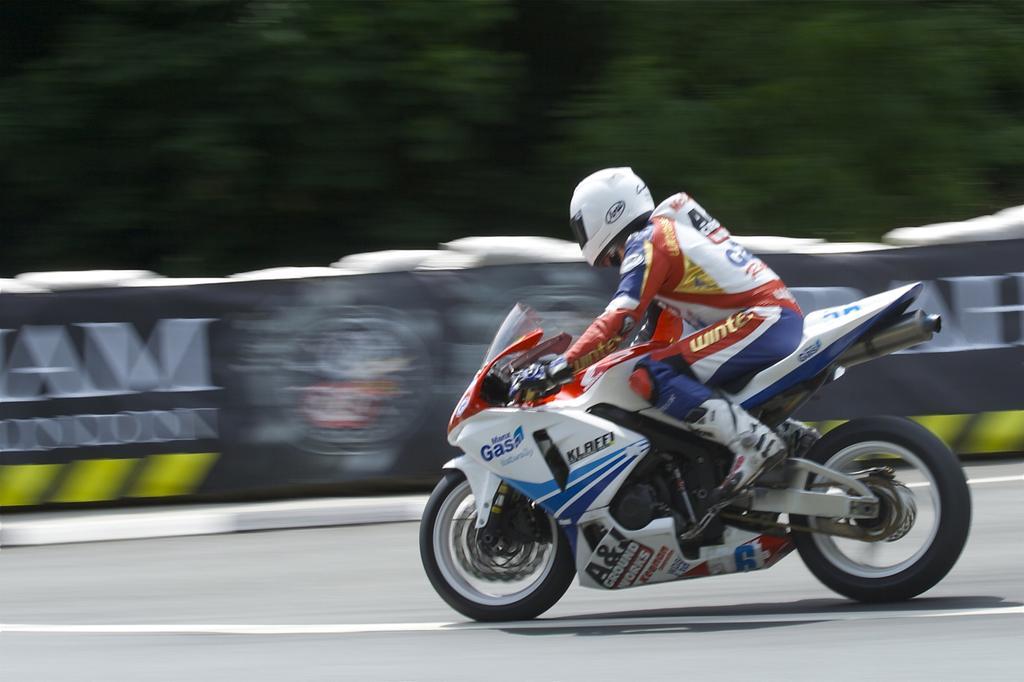Can you describe this image briefly? In this image we can see a person wearing helmet and gloves. He is riding a motorcycle on the road. In the background it is blur. And we can see objects like banners. 